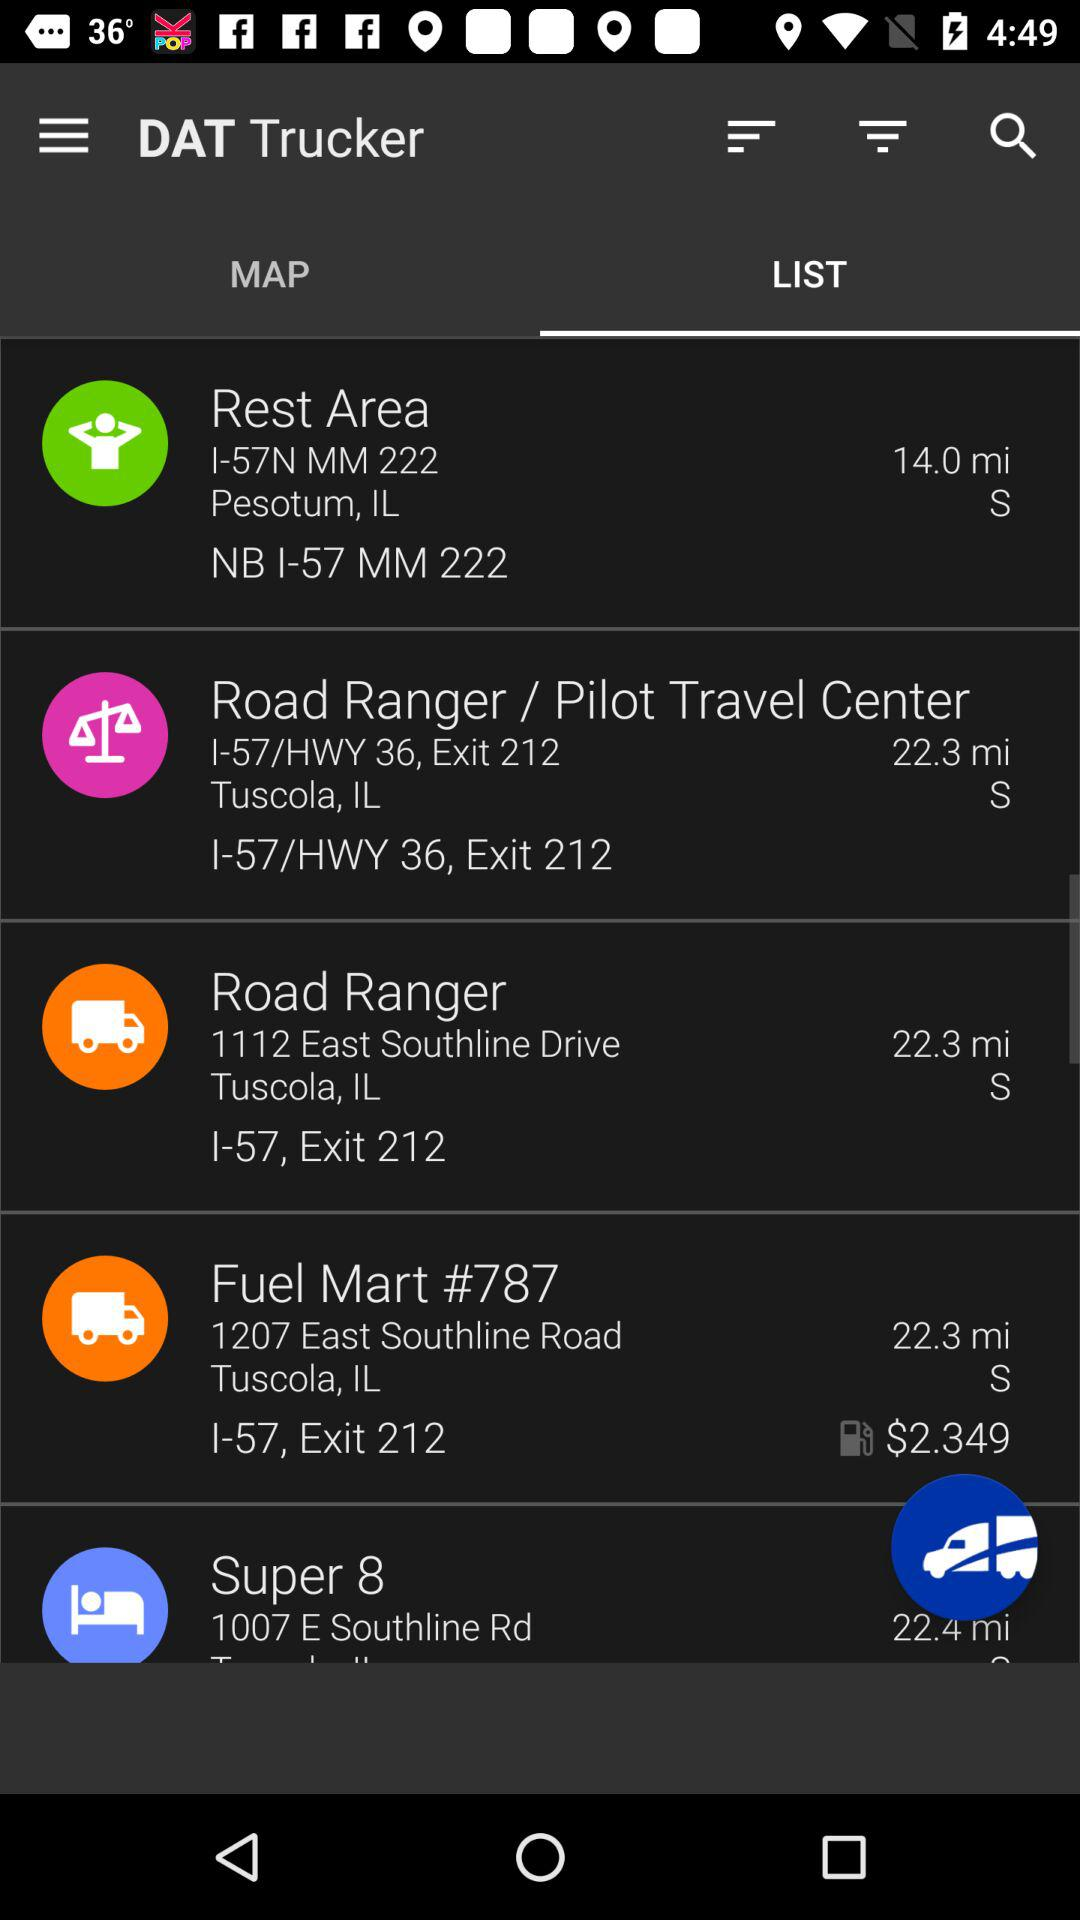What is the name of the application? The name of the application is "DAT Trucker". 